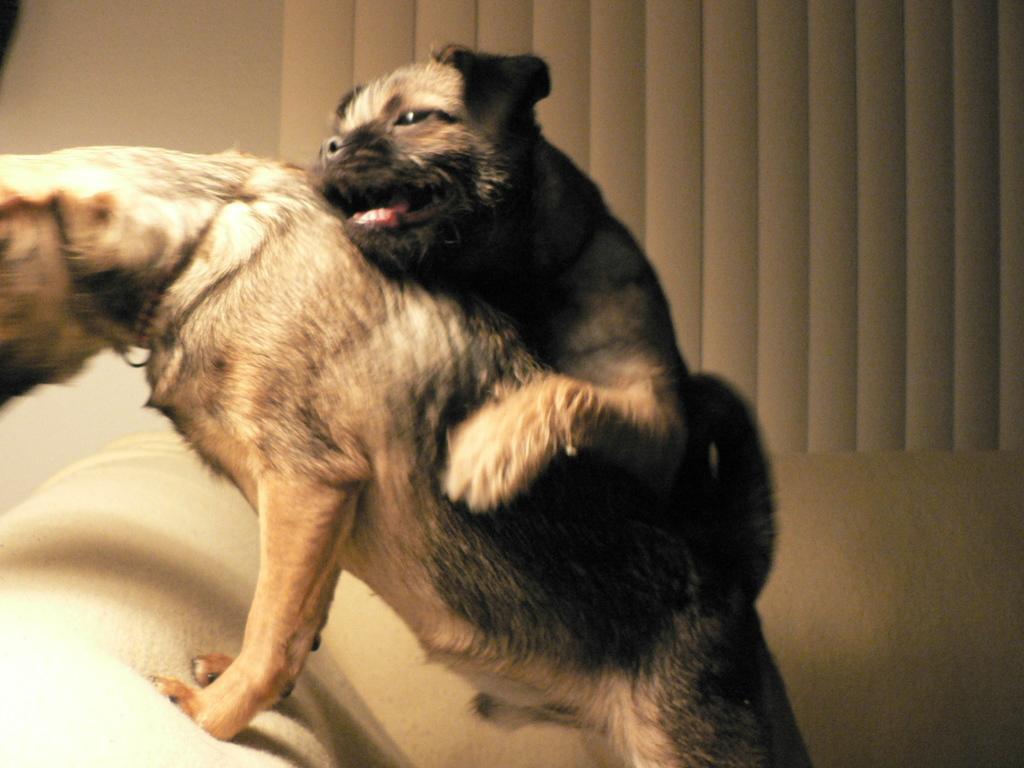Can you describe this image briefly? This picture is clicked inside. In the center we can see the two dogs on the couch. In the background there is an object seems to be the wall. 